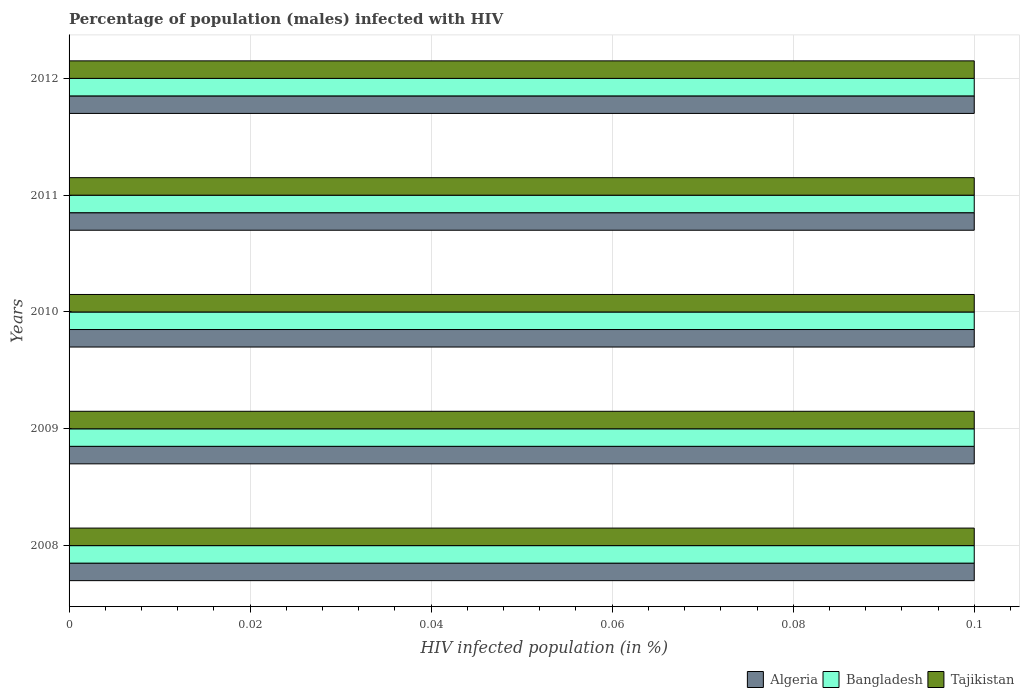How many different coloured bars are there?
Give a very brief answer. 3. Are the number of bars per tick equal to the number of legend labels?
Your response must be concise. Yes. Are the number of bars on each tick of the Y-axis equal?
Offer a very short reply. Yes. How many bars are there on the 2nd tick from the top?
Your response must be concise. 3. How many bars are there on the 4th tick from the bottom?
Make the answer very short. 3. What is the label of the 2nd group of bars from the top?
Your answer should be very brief. 2011. Across all years, what is the minimum percentage of HIV infected male population in Tajikistan?
Give a very brief answer. 0.1. In which year was the percentage of HIV infected male population in Algeria minimum?
Make the answer very short. 2008. What is the total percentage of HIV infected male population in Algeria in the graph?
Your response must be concise. 0.5. What is the difference between the percentage of HIV infected male population in Tajikistan in 2009 and that in 2012?
Offer a very short reply. 0. Is the difference between the percentage of HIV infected male population in Bangladesh in 2010 and 2012 greater than the difference between the percentage of HIV infected male population in Algeria in 2010 and 2012?
Keep it short and to the point. No. What is the difference between the highest and the second highest percentage of HIV infected male population in Bangladesh?
Provide a short and direct response. 0. What is the difference between the highest and the lowest percentage of HIV infected male population in Algeria?
Provide a succinct answer. 0. In how many years, is the percentage of HIV infected male population in Tajikistan greater than the average percentage of HIV infected male population in Tajikistan taken over all years?
Keep it short and to the point. 0. Is the sum of the percentage of HIV infected male population in Bangladesh in 2008 and 2011 greater than the maximum percentage of HIV infected male population in Tajikistan across all years?
Your answer should be compact. Yes. What does the 3rd bar from the top in 2008 represents?
Your answer should be compact. Algeria. What does the 1st bar from the bottom in 2012 represents?
Offer a terse response. Algeria. How many bars are there?
Your answer should be very brief. 15. Does the graph contain any zero values?
Your response must be concise. No. How many legend labels are there?
Make the answer very short. 3. How are the legend labels stacked?
Provide a succinct answer. Horizontal. What is the title of the graph?
Ensure brevity in your answer.  Percentage of population (males) infected with HIV. Does "Sao Tome and Principe" appear as one of the legend labels in the graph?
Offer a very short reply. No. What is the label or title of the X-axis?
Offer a very short reply. HIV infected population (in %). What is the HIV infected population (in %) in Algeria in 2008?
Make the answer very short. 0.1. What is the HIV infected population (in %) of Bangladesh in 2008?
Your response must be concise. 0.1. What is the HIV infected population (in %) of Algeria in 2009?
Your answer should be compact. 0.1. What is the HIV infected population (in %) in Bangladesh in 2009?
Your answer should be compact. 0.1. What is the HIV infected population (in %) in Bangladesh in 2010?
Provide a short and direct response. 0.1. What is the HIV infected population (in %) of Tajikistan in 2010?
Your answer should be compact. 0.1. What is the HIV infected population (in %) of Tajikistan in 2012?
Your answer should be compact. 0.1. Across all years, what is the maximum HIV infected population (in %) in Tajikistan?
Your response must be concise. 0.1. Across all years, what is the minimum HIV infected population (in %) of Algeria?
Provide a succinct answer. 0.1. What is the total HIV infected population (in %) in Algeria in the graph?
Your answer should be very brief. 0.5. What is the total HIV infected population (in %) of Bangladesh in the graph?
Give a very brief answer. 0.5. What is the difference between the HIV infected population (in %) in Tajikistan in 2008 and that in 2009?
Make the answer very short. 0. What is the difference between the HIV infected population (in %) of Bangladesh in 2008 and that in 2010?
Make the answer very short. 0. What is the difference between the HIV infected population (in %) of Bangladesh in 2008 and that in 2011?
Make the answer very short. 0. What is the difference between the HIV infected population (in %) of Algeria in 2008 and that in 2012?
Your answer should be compact. 0. What is the difference between the HIV infected population (in %) of Tajikistan in 2008 and that in 2012?
Provide a short and direct response. 0. What is the difference between the HIV infected population (in %) of Algeria in 2009 and that in 2010?
Provide a short and direct response. 0. What is the difference between the HIV infected population (in %) of Algeria in 2009 and that in 2011?
Offer a terse response. 0. What is the difference between the HIV infected population (in %) in Bangladesh in 2009 and that in 2011?
Give a very brief answer. 0. What is the difference between the HIV infected population (in %) in Tajikistan in 2009 and that in 2011?
Offer a very short reply. 0. What is the difference between the HIV infected population (in %) in Bangladesh in 2009 and that in 2012?
Provide a short and direct response. 0. What is the difference between the HIV infected population (in %) of Algeria in 2010 and that in 2012?
Keep it short and to the point. 0. What is the difference between the HIV infected population (in %) in Algeria in 2008 and the HIV infected population (in %) in Tajikistan in 2009?
Keep it short and to the point. 0. What is the difference between the HIV infected population (in %) in Bangladesh in 2008 and the HIV infected population (in %) in Tajikistan in 2009?
Your answer should be very brief. 0. What is the difference between the HIV infected population (in %) of Algeria in 2008 and the HIV infected population (in %) of Tajikistan in 2010?
Your answer should be compact. 0. What is the difference between the HIV infected population (in %) of Bangladesh in 2008 and the HIV infected population (in %) of Tajikistan in 2010?
Ensure brevity in your answer.  0. What is the difference between the HIV infected population (in %) in Algeria in 2008 and the HIV infected population (in %) in Tajikistan in 2011?
Provide a short and direct response. 0. What is the difference between the HIV infected population (in %) of Bangladesh in 2008 and the HIV infected population (in %) of Tajikistan in 2011?
Keep it short and to the point. 0. What is the difference between the HIV infected population (in %) of Bangladesh in 2008 and the HIV infected population (in %) of Tajikistan in 2012?
Your answer should be compact. 0. What is the difference between the HIV infected population (in %) of Algeria in 2009 and the HIV infected population (in %) of Bangladesh in 2010?
Keep it short and to the point. 0. What is the difference between the HIV infected population (in %) of Algeria in 2009 and the HIV infected population (in %) of Tajikistan in 2010?
Offer a very short reply. 0. What is the difference between the HIV infected population (in %) in Algeria in 2009 and the HIV infected population (in %) in Bangladesh in 2011?
Offer a terse response. 0. What is the difference between the HIV infected population (in %) in Bangladesh in 2009 and the HIV infected population (in %) in Tajikistan in 2011?
Provide a short and direct response. 0. What is the difference between the HIV infected population (in %) in Algeria in 2009 and the HIV infected population (in %) in Bangladesh in 2012?
Offer a very short reply. 0. What is the difference between the HIV infected population (in %) in Algeria in 2010 and the HIV infected population (in %) in Tajikistan in 2011?
Your answer should be compact. 0. What is the difference between the HIV infected population (in %) in Bangladesh in 2010 and the HIV infected population (in %) in Tajikistan in 2011?
Provide a succinct answer. 0. What is the difference between the HIV infected population (in %) of Algeria in 2010 and the HIV infected population (in %) of Bangladesh in 2012?
Your answer should be compact. 0. What is the difference between the HIV infected population (in %) in Bangladesh in 2010 and the HIV infected population (in %) in Tajikistan in 2012?
Your answer should be compact. 0. What is the difference between the HIV infected population (in %) of Algeria in 2011 and the HIV infected population (in %) of Bangladesh in 2012?
Ensure brevity in your answer.  0. What is the difference between the HIV infected population (in %) of Algeria in 2011 and the HIV infected population (in %) of Tajikistan in 2012?
Your answer should be compact. 0. What is the difference between the HIV infected population (in %) of Bangladesh in 2011 and the HIV infected population (in %) of Tajikistan in 2012?
Provide a short and direct response. 0. What is the average HIV infected population (in %) in Algeria per year?
Your answer should be very brief. 0.1. What is the average HIV infected population (in %) in Tajikistan per year?
Make the answer very short. 0.1. In the year 2008, what is the difference between the HIV infected population (in %) in Algeria and HIV infected population (in %) in Tajikistan?
Give a very brief answer. 0. In the year 2009, what is the difference between the HIV infected population (in %) in Algeria and HIV infected population (in %) in Tajikistan?
Your answer should be very brief. 0. In the year 2009, what is the difference between the HIV infected population (in %) in Bangladesh and HIV infected population (in %) in Tajikistan?
Make the answer very short. 0. In the year 2010, what is the difference between the HIV infected population (in %) of Algeria and HIV infected population (in %) of Bangladesh?
Ensure brevity in your answer.  0. In the year 2010, what is the difference between the HIV infected population (in %) of Bangladesh and HIV infected population (in %) of Tajikistan?
Give a very brief answer. 0. In the year 2011, what is the difference between the HIV infected population (in %) of Algeria and HIV infected population (in %) of Tajikistan?
Give a very brief answer. 0. In the year 2011, what is the difference between the HIV infected population (in %) of Bangladesh and HIV infected population (in %) of Tajikistan?
Give a very brief answer. 0. In the year 2012, what is the difference between the HIV infected population (in %) in Algeria and HIV infected population (in %) in Bangladesh?
Give a very brief answer. 0. In the year 2012, what is the difference between the HIV infected population (in %) of Bangladesh and HIV infected population (in %) of Tajikistan?
Keep it short and to the point. 0. What is the ratio of the HIV infected population (in %) in Algeria in 2008 to that in 2009?
Provide a succinct answer. 1. What is the ratio of the HIV infected population (in %) in Bangladesh in 2008 to that in 2009?
Keep it short and to the point. 1. What is the ratio of the HIV infected population (in %) in Tajikistan in 2008 to that in 2009?
Provide a short and direct response. 1. What is the ratio of the HIV infected population (in %) in Algeria in 2008 to that in 2010?
Provide a succinct answer. 1. What is the ratio of the HIV infected population (in %) in Bangladesh in 2008 to that in 2012?
Your answer should be very brief. 1. What is the ratio of the HIV infected population (in %) in Tajikistan in 2008 to that in 2012?
Your answer should be very brief. 1. What is the ratio of the HIV infected population (in %) in Algeria in 2009 to that in 2011?
Your answer should be very brief. 1. What is the ratio of the HIV infected population (in %) of Tajikistan in 2009 to that in 2011?
Your answer should be compact. 1. What is the ratio of the HIV infected population (in %) of Algeria in 2009 to that in 2012?
Your answer should be compact. 1. What is the ratio of the HIV infected population (in %) of Tajikistan in 2010 to that in 2011?
Your response must be concise. 1. What is the ratio of the HIV infected population (in %) of Algeria in 2010 to that in 2012?
Your answer should be compact. 1. What is the ratio of the HIV infected population (in %) of Algeria in 2011 to that in 2012?
Your answer should be very brief. 1. What is the ratio of the HIV infected population (in %) of Tajikistan in 2011 to that in 2012?
Keep it short and to the point. 1. What is the difference between the highest and the second highest HIV infected population (in %) of Bangladesh?
Offer a very short reply. 0. What is the difference between the highest and the second highest HIV infected population (in %) in Tajikistan?
Your answer should be compact. 0. What is the difference between the highest and the lowest HIV infected population (in %) in Tajikistan?
Give a very brief answer. 0. 